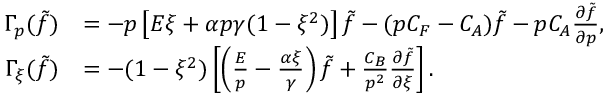<formula> <loc_0><loc_0><loc_500><loc_500>\begin{array} { r l } { \Gamma _ { p } ( \tilde { f } ) } & { = - p \left [ E \xi + \alpha p \gamma ( 1 - \xi ^ { 2 } ) \right ] \tilde { f } - ( p C _ { F } - C _ { A } ) \tilde { f } - p C _ { A } \frac { \partial \tilde { f } } { \partial p } , } \\ { \Gamma _ { \xi } ( \tilde { f } ) } & { = - ( 1 - \xi ^ { 2 } ) \left [ \left ( \frac { E } { p } - \frac { \alpha \xi } { \gamma } \right ) \tilde { f } + \frac { C _ { B } } { p ^ { 2 } } \frac { \partial \tilde { f } } { \partial \xi } \right ] . } \end{array}</formula> 